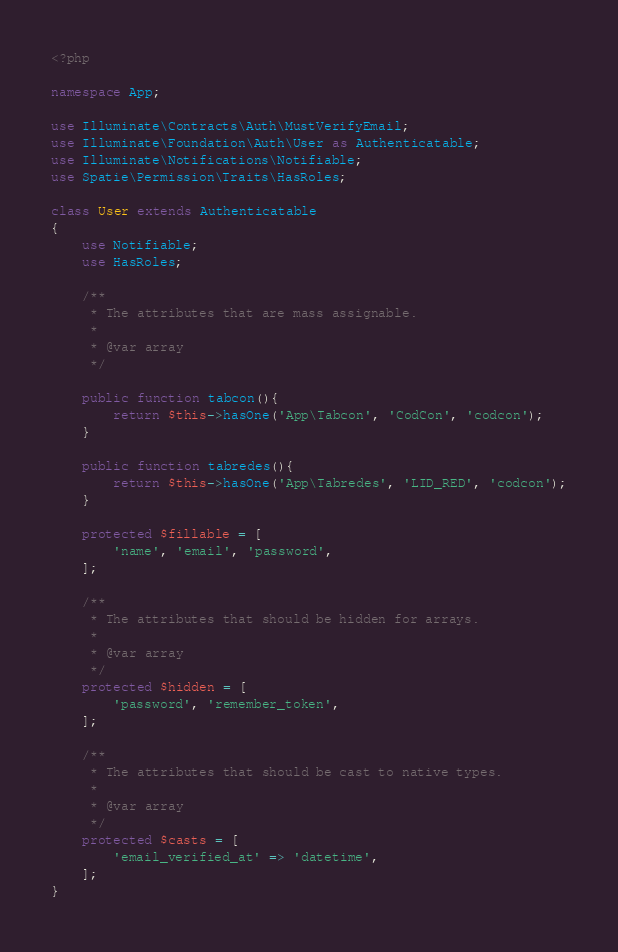<code> <loc_0><loc_0><loc_500><loc_500><_PHP_><?php

namespace App;

use Illuminate\Contracts\Auth\MustVerifyEmail;
use Illuminate\Foundation\Auth\User as Authenticatable;
use Illuminate\Notifications\Notifiable;
use Spatie\Permission\Traits\HasRoles;

class User extends Authenticatable
{
    use Notifiable;
    use HasRoles;

    /**
     * The attributes that are mass assignable.
     *
     * @var array
     */
    
    public function tabcon(){
        return $this->hasOne('App\Tabcon', 'CodCon', 'codcon');
    }

    public function tabredes(){
        return $this->hasOne('App\Tabredes', 'LID_RED', 'codcon');
    }

    protected $fillable = [
        'name', 'email', 'password',
    ];

    /**
     * The attributes that should be hidden for arrays.
     *
     * @var array
     */
    protected $hidden = [
        'password', 'remember_token',
    ];

    /**
     * The attributes that should be cast to native types.
     *
     * @var array
     */
    protected $casts = [
        'email_verified_at' => 'datetime',
    ];
}
</code> 